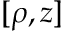Convert formula to latex. <formula><loc_0><loc_0><loc_500><loc_500>[ \rho , z ]</formula> 